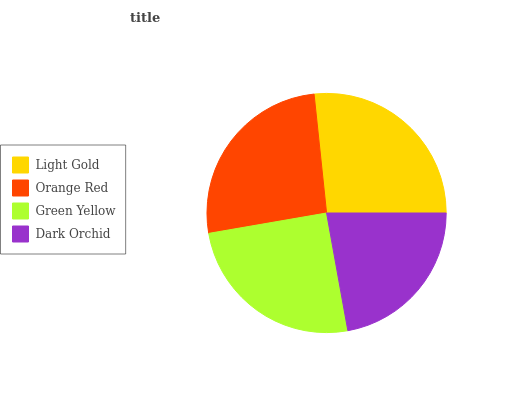Is Dark Orchid the minimum?
Answer yes or no. Yes. Is Light Gold the maximum?
Answer yes or no. Yes. Is Orange Red the minimum?
Answer yes or no. No. Is Orange Red the maximum?
Answer yes or no. No. Is Light Gold greater than Orange Red?
Answer yes or no. Yes. Is Orange Red less than Light Gold?
Answer yes or no. Yes. Is Orange Red greater than Light Gold?
Answer yes or no. No. Is Light Gold less than Orange Red?
Answer yes or no. No. Is Orange Red the high median?
Answer yes or no. Yes. Is Green Yellow the low median?
Answer yes or no. Yes. Is Dark Orchid the high median?
Answer yes or no. No. Is Orange Red the low median?
Answer yes or no. No. 